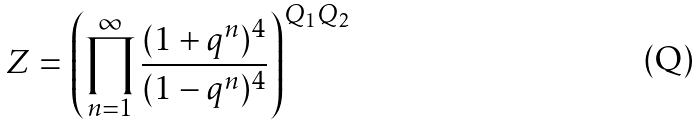<formula> <loc_0><loc_0><loc_500><loc_500>Z = \left ( \prod _ { n = 1 } ^ { \infty } \frac { ( 1 + q ^ { n } ) ^ { 4 } } { ( 1 - q ^ { n } ) ^ { 4 } } \right ) ^ { Q _ { 1 } Q _ { 2 } }</formula> 